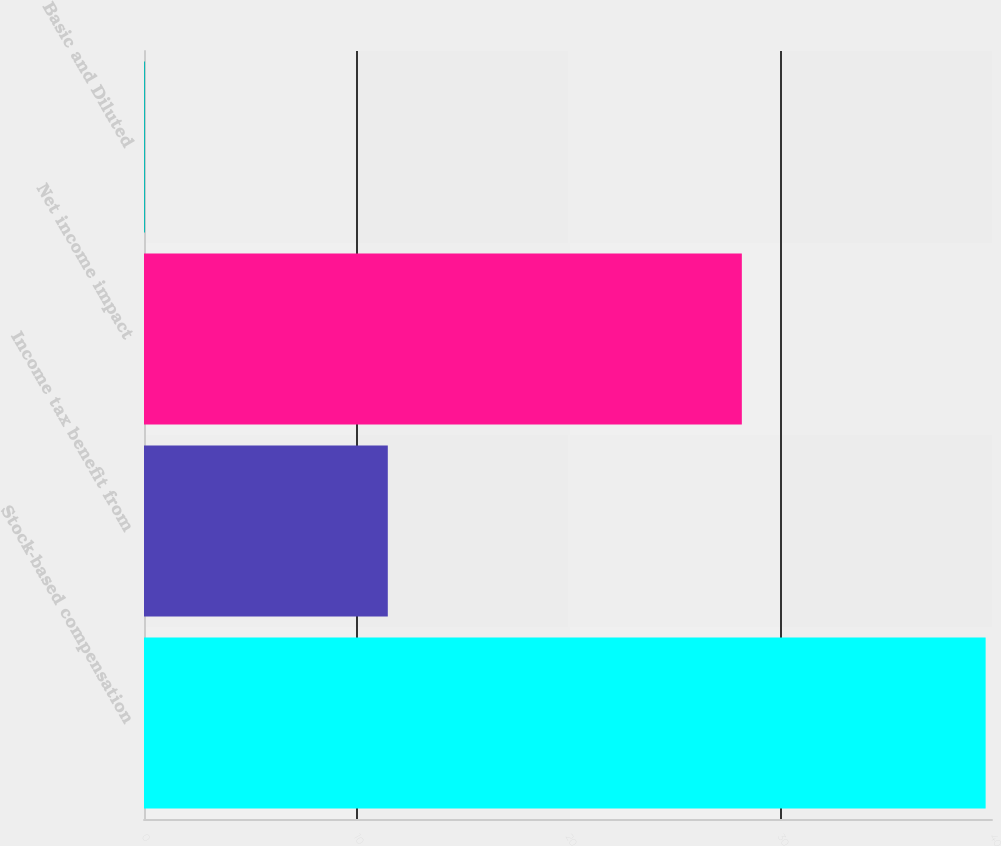<chart> <loc_0><loc_0><loc_500><loc_500><bar_chart><fcel>Stock-based compensation<fcel>Income tax benefit from<fcel>Net income impact<fcel>Basic and Diluted<nl><fcel>39.7<fcel>11.5<fcel>28.2<fcel>0.05<nl></chart> 